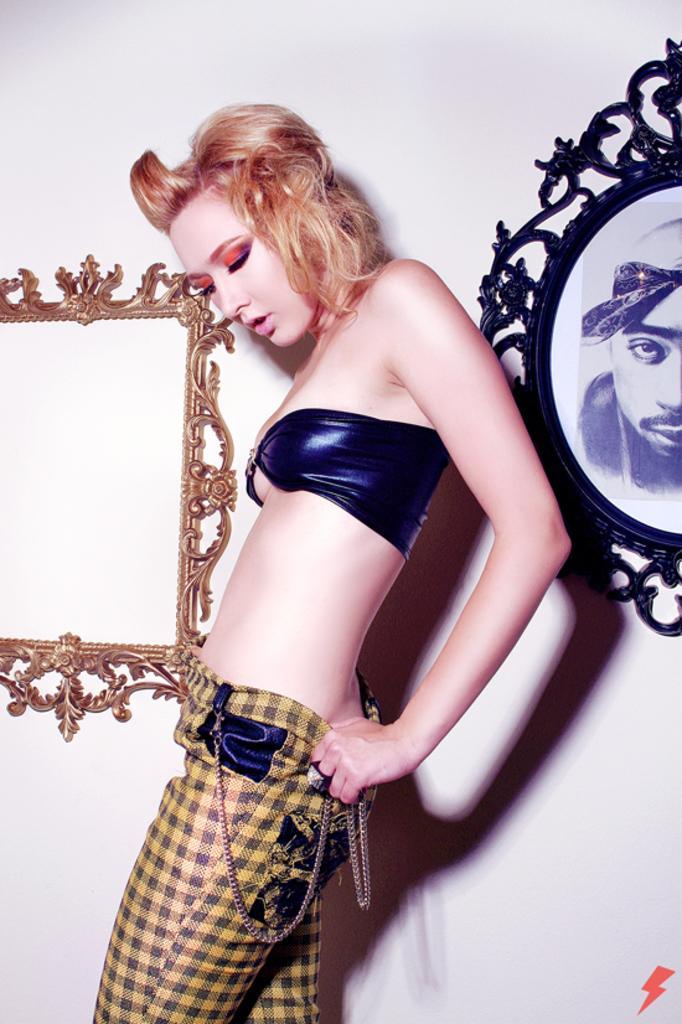Could you give a brief overview of what you see in this image? In the center of the picture there is a woman standing. On the right there is a frame. On the left there is a frame. The wall is painted white. 